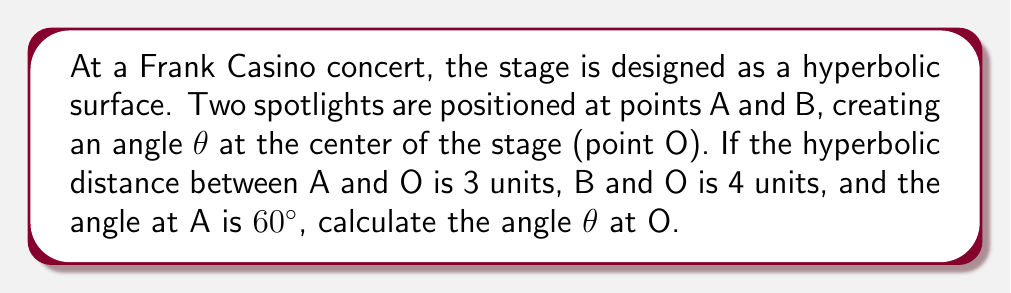What is the answer to this math problem? Let's approach this step-by-step using hyperbolic geometry:

1) In hyperbolic geometry, we use the hyperbolic law of cosines:

   $$\cosh c = \cosh a \cosh b - \sinh a \sinh b \cos C$$

   Where a, b, and c are the lengths of the sides, and C is the angle opposite side c.

2) We're given:
   - AO = 3 units
   - BO = 4 units
   - Angle at A = 60° = π/3 radians

3) Let's call the side AB as c. We need to find θ, which is the angle at O.

4) Using the hyperbolic law of cosines:

   $$\cosh c = \cosh 3 \cosh 4 - \sinh 3 \sinh 4 \cos(\pi/3)$$

5) Calculate the hyperbolic functions:
   $$\cosh 3 \approx 10.0677$$
   $$\cosh 4 \approx 27.3082$$
   $$\sinh 3 \approx 10.0179$$
   $$\sinh 4 \approx 27.2899$$
   $$\cos(\pi/3) = 0.5$$

6) Substitute these values:

   $$\cosh c = 10.0677 * 27.3082 - 10.0179 * 27.2899 * 0.5 \approx 137.2809$$

7) Now we can use the hyperbolic law of cosines again to find θ:

   $$\cos θ = \frac{\cosh 3 \cosh 4 - \cosh c}{\sinh 3 \sinh 4}$$

8) Substitute the values:

   $$\cos θ = \frac{10.0677 * 27.3082 - 137.2809}{10.0179 * 27.2899} \approx 0.5$$

9) Therefore:

   $$θ = \arccos(0.5) = \frac{\pi}{3} \text{ radians} = 60°$$
Answer: 60° 